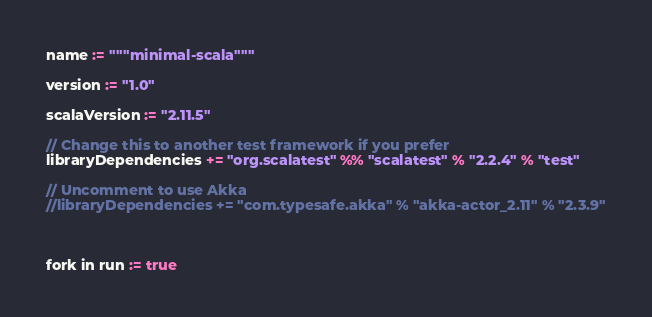<code> <loc_0><loc_0><loc_500><loc_500><_Scala_>name := """minimal-scala"""

version := "1.0"

scalaVersion := "2.11.5"

// Change this to another test framework if you prefer
libraryDependencies += "org.scalatest" %% "scalatest" % "2.2.4" % "test"

// Uncomment to use Akka
//libraryDependencies += "com.typesafe.akka" % "akka-actor_2.11" % "2.3.9"



fork in run := true</code> 